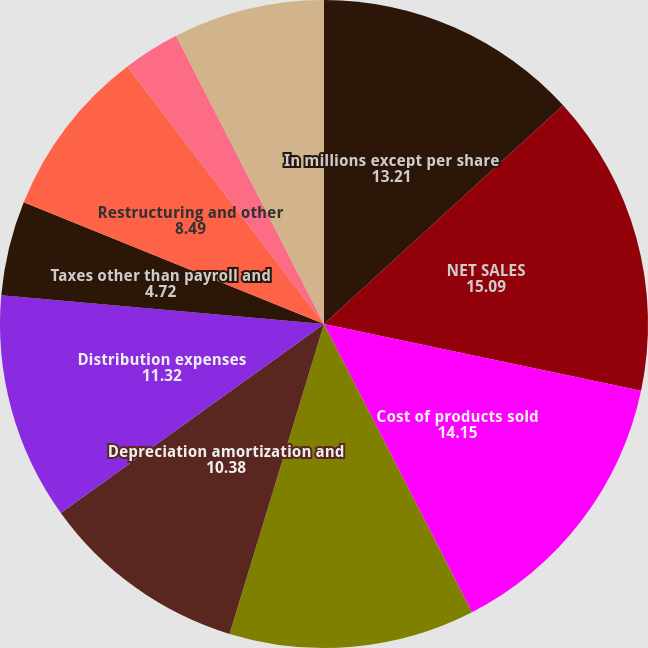Convert chart. <chart><loc_0><loc_0><loc_500><loc_500><pie_chart><fcel>In millions except per share<fcel>NET SALES<fcel>Cost of products sold<fcel>Selling and administrative<fcel>Depreciation amortization and<fcel>Distribution expenses<fcel>Taxes other than payroll and<fcel>Restructuring and other<fcel>Net (gains) losses on sales<fcel>Interest expense net<nl><fcel>13.21%<fcel>15.09%<fcel>14.15%<fcel>12.26%<fcel>10.38%<fcel>11.32%<fcel>4.72%<fcel>8.49%<fcel>2.83%<fcel>7.55%<nl></chart> 